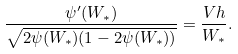Convert formula to latex. <formula><loc_0><loc_0><loc_500><loc_500>\frac { \psi ^ { \prime } ( W _ { * } ) } { \sqrt { 2 \psi ( W _ { * } ) ( 1 - 2 \psi ( W _ { * } ) ) } } = \frac { V h } { W _ { * } } .</formula> 